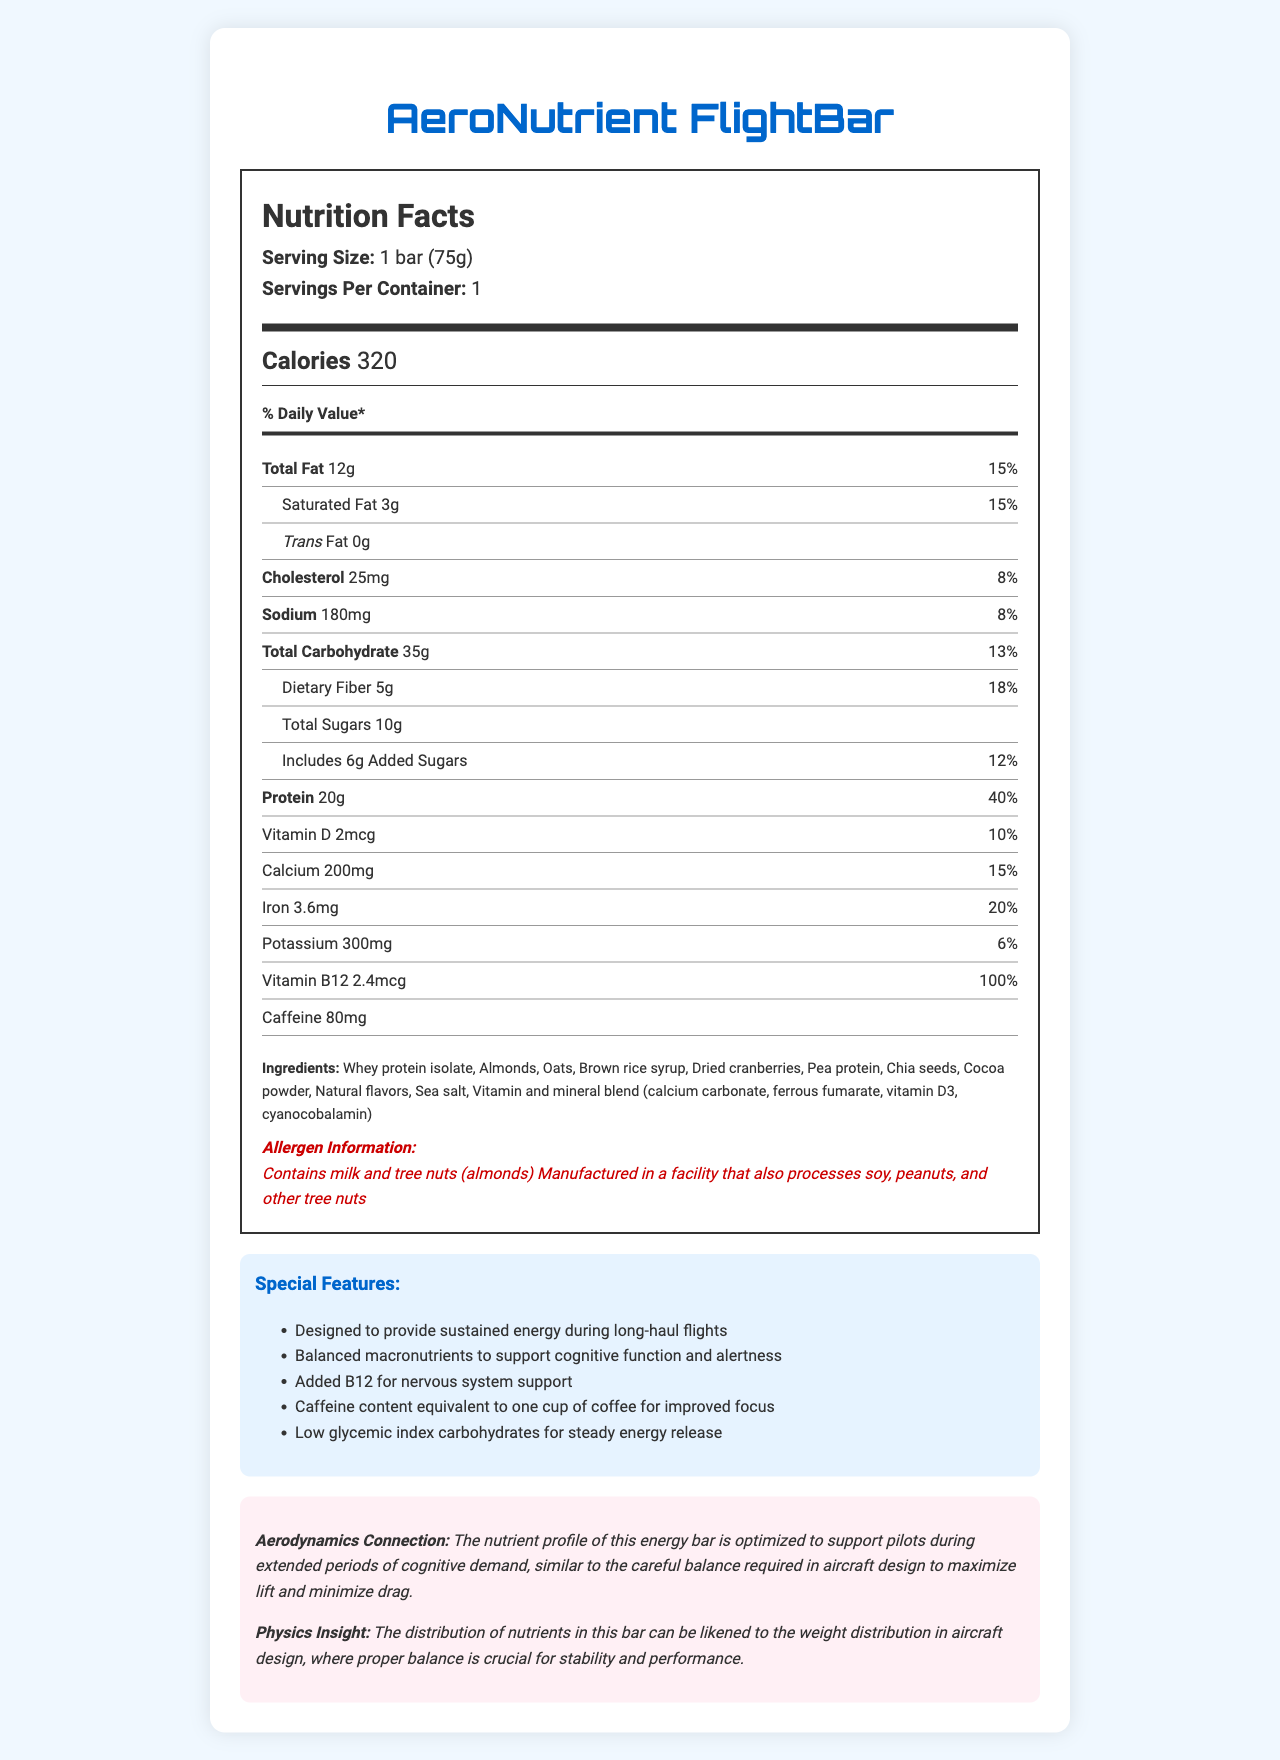what is the serving size? The serving size is clearly stated in the document as "1 bar (75g)".
Answer: 1 bar (75g) how many calories are in one serving of AeroNutrient FlightBar? The document lists the calories per serving as 320.
Answer: 320 calories what is the total fat content per serving? The total fat content is specified in the document as "12g".
Answer: 12g how many grams of protein does each bar contain? The protein content for each bar is given as "20g".
Answer: 20g what is the daily value percentage for calcium? The daily value percentage for calcium is listed as "15%" in the document.
Answer: 15% what allergens are present in AeroNutrient FlightBar? The allergens are specified under the "Allergen Information" section.
Answer: Contains milk and tree nuts (almonds); Manufactured in a facility that also processes soy, peanuts, and other tree nuts how much caffeine does each bar contain? The caffeine content per bar is given as "80mg".
Answer: 80mg what ingredients give the bar its protein content? A. Almonds B. Oats C. Whey protein isolate D. All of the above Ingredients like whey protein isolate, almonds, and oats contribute to the protein content in the bar.
Answer: D. All of the above which nutrient has the highest daily value percentage? A. Vitamin D B. Iron C. Dietary Fiber D. Vitamin B12 The daily value for Vitamin B12 is 100%, which is the highest among the listed nutrients.
Answer: D. Vitamin B12 is the AeroNutrient FlightBar designed to support cognitive function and alertness? One of the special features states that the bar is designed to support cognitive function and alertness.
Answer: Yes does the AeroNutrient FlightBar contain any trans fat? The document specifies that the trans fat content is "0g".
Answer: No provide a summary of the AeroNutrient FlightBar's nutrition facts and special features. The document provides detailed nutrition facts, ingredients, allergen information, and special features aimed at providing sustained energy and supporting cognitive function for pilots.
Answer: The AeroNutrient FlightBar has a serving size of 1 bar (75g) with 320 calories. It contains 12g of total fat, 20g of protein, and provides various vitamins and minerals including Vitamin D, calcium, iron, and Vitamin B12. Special features include sustained energy, balanced macronutrients, added B12 for nervous system support, and caffeine content for improved focus. It also has a low glycemic index. The bar's nutrient profile supports pilots during long-haul flights. what is the glycemic index of the AeroNutrient FlightBar? The document mentions that the bar has a low glycemic index but does not provide a specific value for the glycemic index.
Answer: Not enough information 